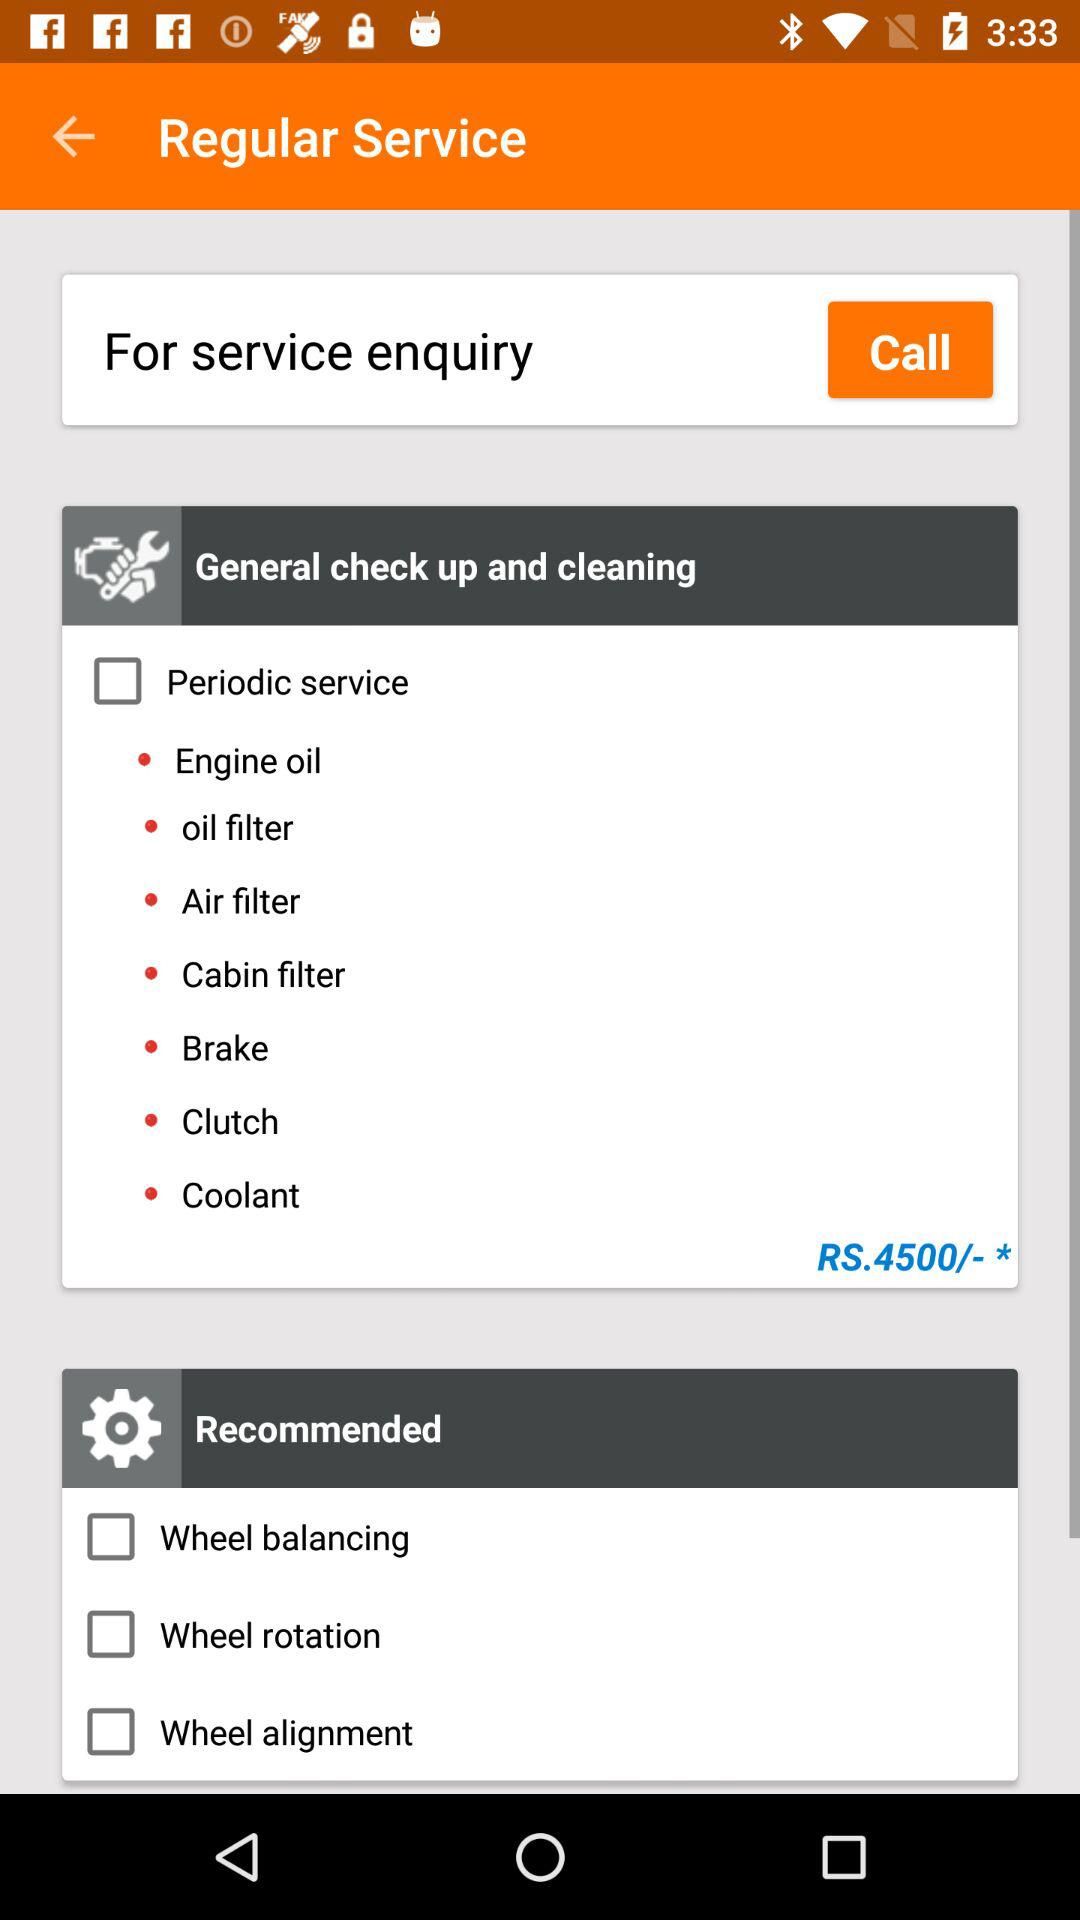What options are available for periodic service? The options available are: engine oil, oil filter, air filter, cabin filter, brake, clutch and coolant. 